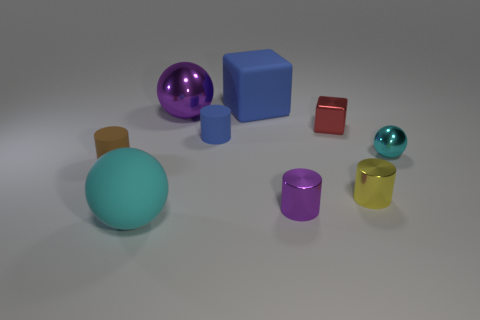Does the blue cylinder have the same material as the sphere on the right side of the big blue block?
Your response must be concise. No. Is the number of big blue blocks left of the purple shiny cylinder less than the number of blue blocks that are in front of the large rubber ball?
Your answer should be very brief. No. The big rubber object that is left of the rubber cube is what color?
Your response must be concise. Cyan. How many other objects are the same color as the shiny block?
Provide a succinct answer. 0. There is a sphere on the right side of the red object; is its size the same as the yellow metal thing?
Offer a terse response. Yes. What number of balls are behind the big purple metal sphere?
Your answer should be very brief. 0. Is there a purple cylinder that has the same size as the yellow thing?
Offer a terse response. Yes. Is the large rubber block the same color as the small cube?
Ensure brevity in your answer.  No. There is a small rubber cylinder that is right of the small matte object to the left of the purple shiny sphere; what color is it?
Your answer should be compact. Blue. What number of blue objects are in front of the large blue matte block and to the right of the small blue rubber thing?
Make the answer very short. 0. 